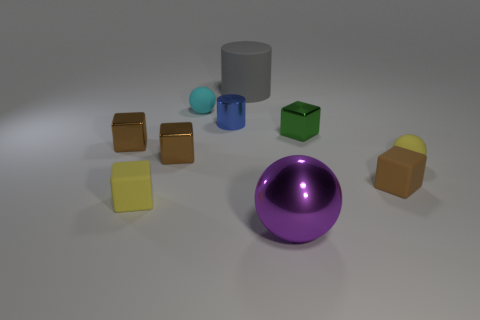Is the number of small yellow rubber things that are left of the tiny green metallic cube greater than the number of big purple shiny cylinders?
Provide a succinct answer. Yes. How many other things are the same color as the large cylinder?
Give a very brief answer. 0. Are there more shiny cylinders than tiny gray matte things?
Offer a terse response. Yes. What material is the large sphere?
Keep it short and to the point. Metal. Is the size of the yellow matte object that is on the right side of the blue shiny thing the same as the small cyan rubber object?
Your response must be concise. Yes. How big is the purple metal ball in front of the yellow rubber block?
Keep it short and to the point. Large. What number of cyan balls are there?
Provide a succinct answer. 1. The sphere that is both right of the big gray rubber cylinder and to the left of the yellow sphere is what color?
Your answer should be compact. Purple. There is a yellow cube; are there any large objects in front of it?
Your answer should be very brief. Yes. How many small blue shiny things are to the right of the shiny thing that is right of the big purple sphere?
Your response must be concise. 0. 